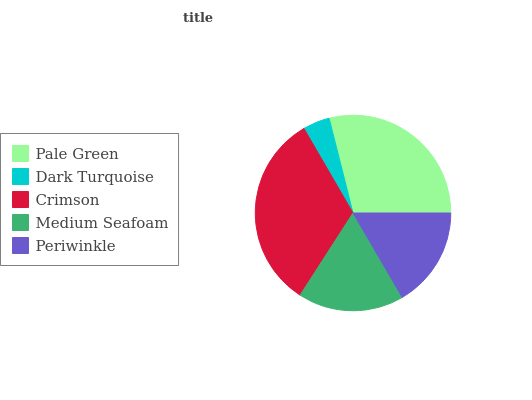Is Dark Turquoise the minimum?
Answer yes or no. Yes. Is Crimson the maximum?
Answer yes or no. Yes. Is Crimson the minimum?
Answer yes or no. No. Is Dark Turquoise the maximum?
Answer yes or no. No. Is Crimson greater than Dark Turquoise?
Answer yes or no. Yes. Is Dark Turquoise less than Crimson?
Answer yes or no. Yes. Is Dark Turquoise greater than Crimson?
Answer yes or no. No. Is Crimson less than Dark Turquoise?
Answer yes or no. No. Is Medium Seafoam the high median?
Answer yes or no. Yes. Is Medium Seafoam the low median?
Answer yes or no. Yes. Is Crimson the high median?
Answer yes or no. No. Is Pale Green the low median?
Answer yes or no. No. 